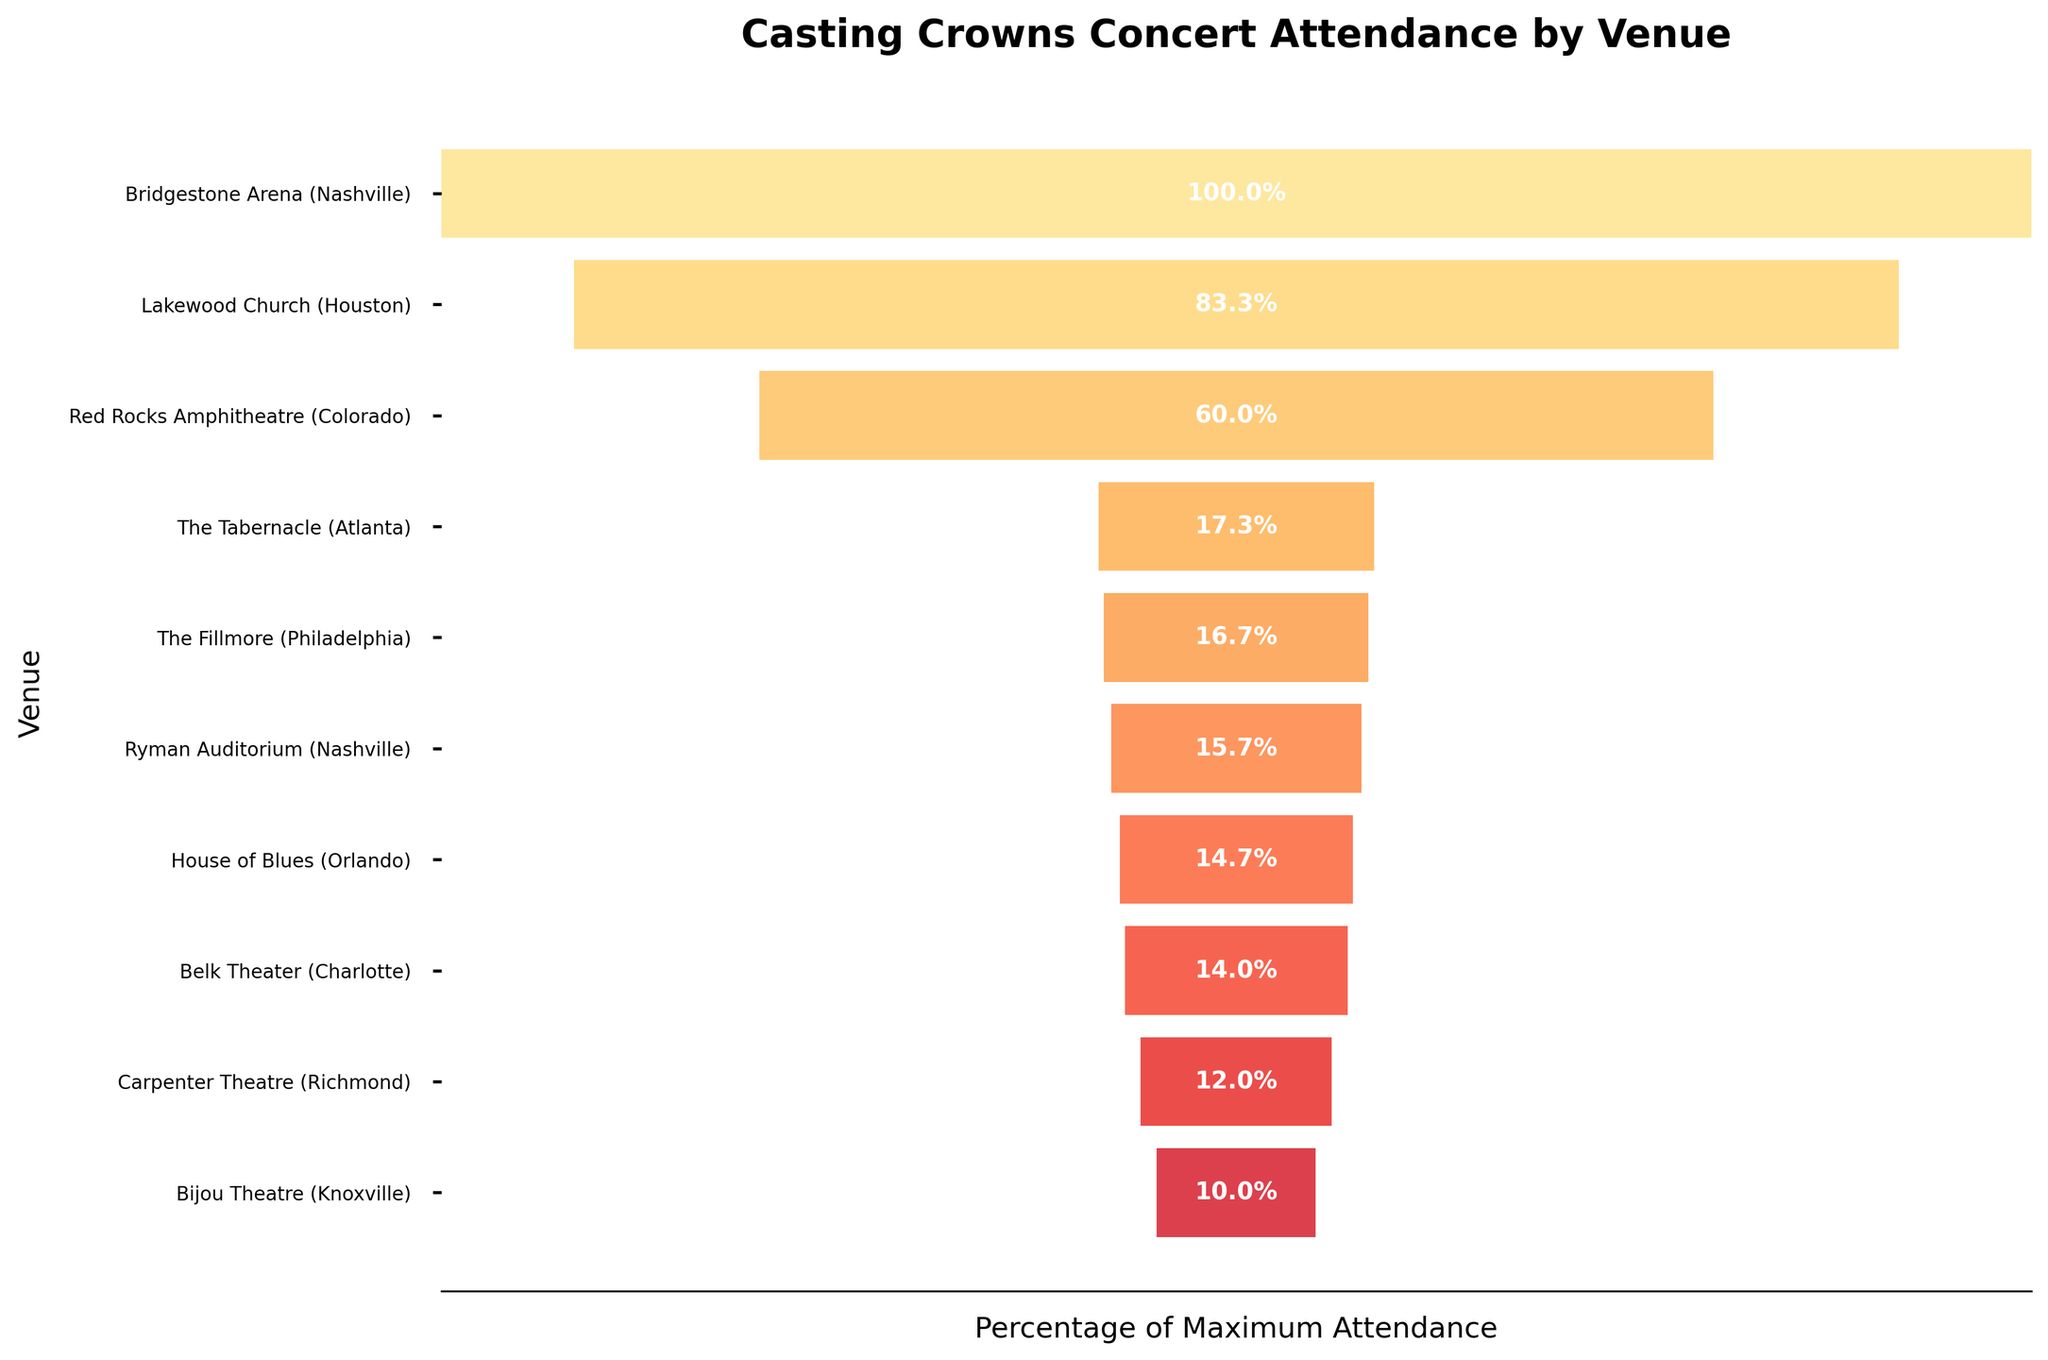How many venues are displayed in the figure? There are 10 venues listed on the y-axis of the funnel chart.
Answer: 10 Which venue had the highest attendance? The venue with the highest attendance is Bridgestone Arena (Nashville), as seen at the top of the chart.
Answer: Bridgestone Arena (Nashville) What is the percentage of attendance for Lakewood Church (Houston)? Lakewood Church (Houston) is second from the top, and its attendance percentage is shown as approximately 83.3%.
Answer: 83.3% Which venue had the lowest attendance? The venue with the lowest attendance is Bijou Theatre (Knoxville), located at the bottom of the chart.
Answer: Bijou Theatre (Knoxville) How do the attendance numbers compare between The Fillmore (Philadelphia) and The Ryman Auditorium (Nashville)? The Fillmore (Philadelphia) has higher attendance (2500) compared to The Ryman Auditorium (Nashville) (2362).
Answer: The Fillmore (Philadelphia) has higher attendance What is the percentage difference in attendance between the top and bottom venues? The top venue (Bridgestone Arena) has 100%, while the bottom venue (Bijou Theatre) has approximately 10%, leading to a percentage difference of 90%.
Answer: 90% If you combined the attendance of The Tabernacle (Atlanta) and House of Blues (Orlando), what would their combined percentage be? The Tabernacle (Atlanta) has 17.3% and House of Blues (Orlando) has 14.7%, combined they would be 17.3% + 14.7% = 32%.
Answer: 32% Does Red Rocks Amphitheatre (Colorado) have higher attendance than the Ryman Auditorium (Nashville)? Yes, Red Rocks Amphitheatre (Colorado) has an attendance of 9000, which is higher than the Ryman Auditorium (Nashville) with 2362.
Answer: Yes How many venues have an attendance percentage less than 20%? There are 6 venues with an attendance percentage less than 20%: Ryman Auditorium, The Tabernacle, House of Blues, Belk Theater, Carpenter Theatre, and Bijou Theatre.
Answer: 6 What's the average attendance of the venues shown? Sum all the attendances (15000 + 12500 + 9000 + 2362 + 2600 + 2200 + 2100 + 1800 + 2500 + 1500) = 51162, and divide by the number of venues (10), so the average attendance = 51162 / 10 = 5116.2.
Answer: 5116.2 